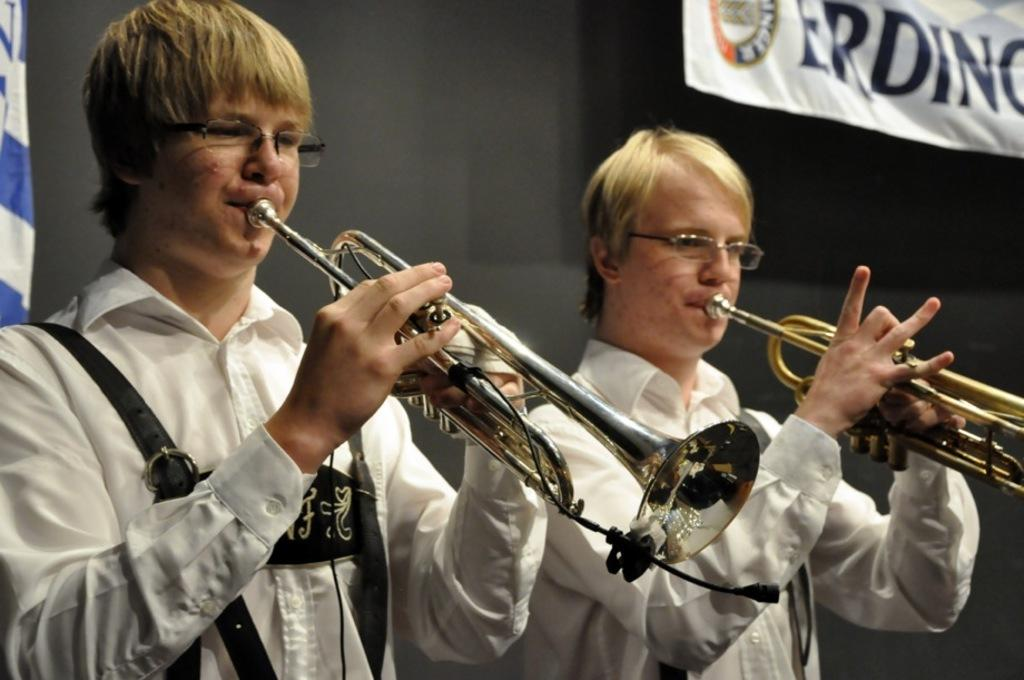How many people are present in the image? There are two people in the image. What are the two people doing in the image? The two people are playing musical instruments. What can be seen in the background of the image? There is a wall visible in the image. Is there any additional signage or decoration in the image? Yes, there is a banner in the image. How many tents can be seen in the image? There are no tents present in the image. What type of crook is involved in the musical performance in the image? There is no crook involved in the musical performance in the image; it is a scene of people playing musical instruments. 